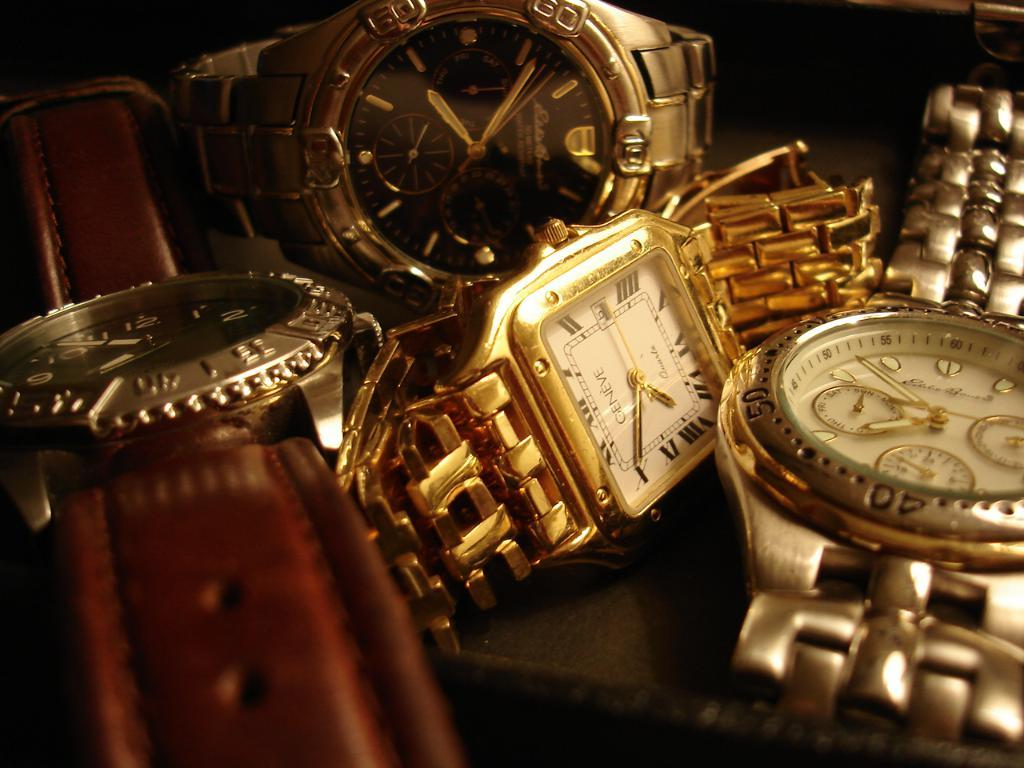<image>
Write a terse but informative summary of the picture. Four watches placed next to each other with one that is branded Geneve. 